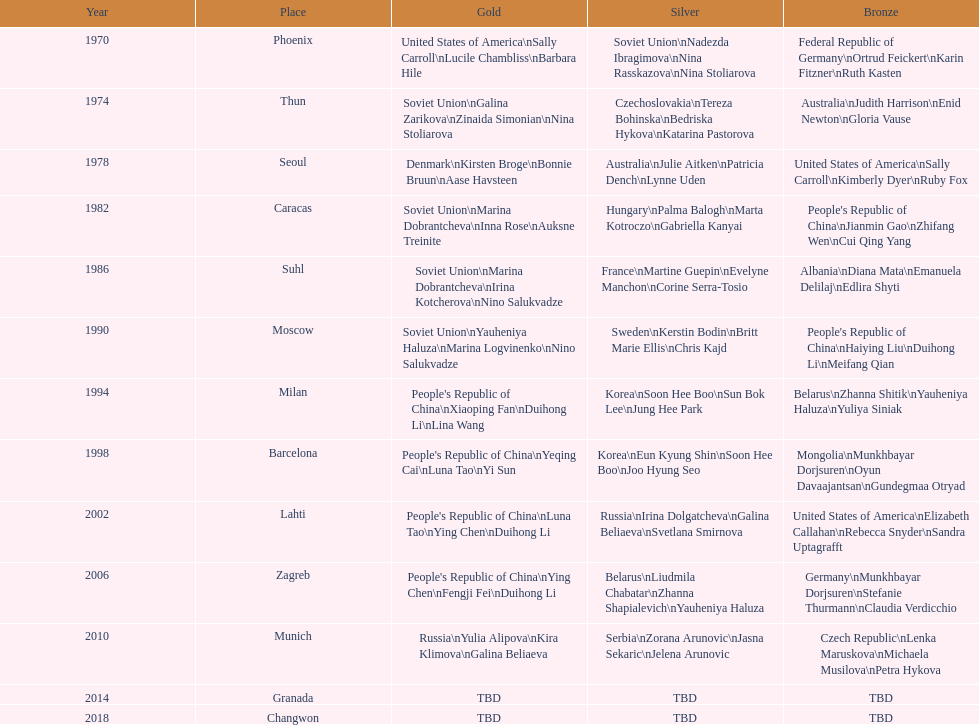Which nation has the highest occurrence in the silver column? Korea. 